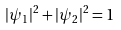Convert formula to latex. <formula><loc_0><loc_0><loc_500><loc_500>| \psi _ { 1 } | ^ { 2 } + | \psi _ { 2 } | ^ { 2 } = 1</formula> 